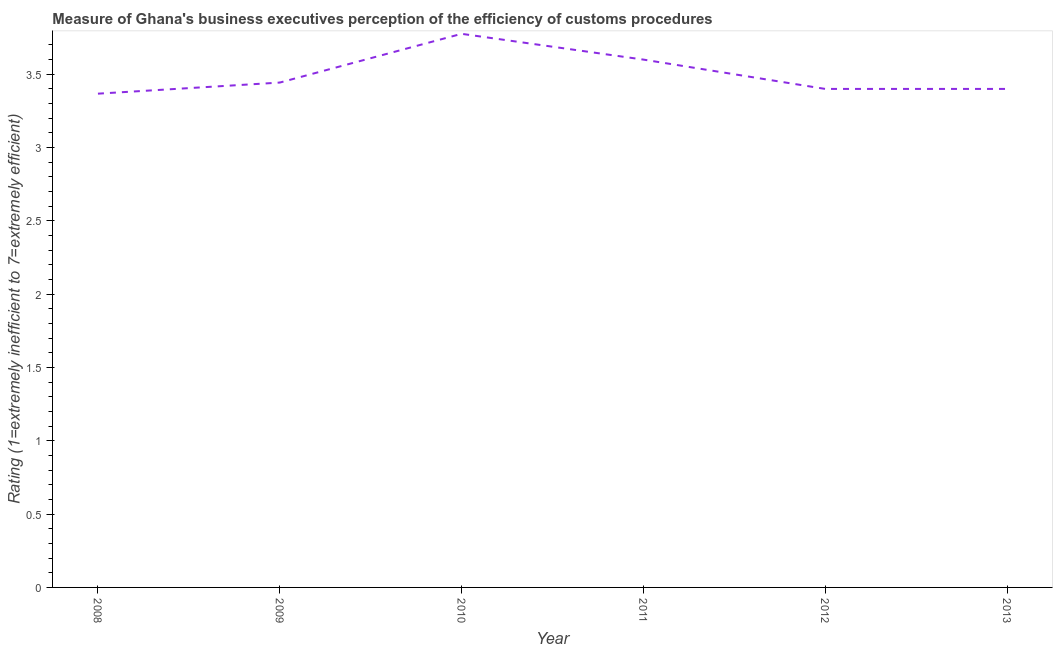Across all years, what is the maximum rating measuring burden of customs procedure?
Make the answer very short. 3.78. Across all years, what is the minimum rating measuring burden of customs procedure?
Your answer should be very brief. 3.37. In which year was the rating measuring burden of customs procedure maximum?
Provide a succinct answer. 2010. In which year was the rating measuring burden of customs procedure minimum?
Your answer should be compact. 2008. What is the sum of the rating measuring burden of customs procedure?
Make the answer very short. 20.99. What is the difference between the rating measuring burden of customs procedure in 2010 and 2011?
Give a very brief answer. 0.18. What is the average rating measuring burden of customs procedure per year?
Ensure brevity in your answer.  3.5. What is the median rating measuring burden of customs procedure?
Ensure brevity in your answer.  3.42. In how many years, is the rating measuring burden of customs procedure greater than 2.3 ?
Make the answer very short. 6. Do a majority of the years between 2009 and 2010 (inclusive) have rating measuring burden of customs procedure greater than 0.7 ?
Provide a succinct answer. Yes. What is the ratio of the rating measuring burden of customs procedure in 2010 to that in 2011?
Your answer should be very brief. 1.05. Is the rating measuring burden of customs procedure in 2010 less than that in 2011?
Provide a succinct answer. No. Is the difference between the rating measuring burden of customs procedure in 2008 and 2009 greater than the difference between any two years?
Provide a succinct answer. No. What is the difference between the highest and the second highest rating measuring burden of customs procedure?
Make the answer very short. 0.18. Is the sum of the rating measuring burden of customs procedure in 2010 and 2012 greater than the maximum rating measuring burden of customs procedure across all years?
Ensure brevity in your answer.  Yes. What is the difference between the highest and the lowest rating measuring burden of customs procedure?
Your answer should be compact. 0.41. In how many years, is the rating measuring burden of customs procedure greater than the average rating measuring burden of customs procedure taken over all years?
Keep it short and to the point. 2. How many lines are there?
Provide a succinct answer. 1. How many years are there in the graph?
Your response must be concise. 6. What is the difference between two consecutive major ticks on the Y-axis?
Offer a very short reply. 0.5. Are the values on the major ticks of Y-axis written in scientific E-notation?
Provide a short and direct response. No. Does the graph contain any zero values?
Your answer should be very brief. No. What is the title of the graph?
Make the answer very short. Measure of Ghana's business executives perception of the efficiency of customs procedures. What is the label or title of the Y-axis?
Offer a very short reply. Rating (1=extremely inefficient to 7=extremely efficient). What is the Rating (1=extremely inefficient to 7=extremely efficient) in 2008?
Offer a terse response. 3.37. What is the Rating (1=extremely inefficient to 7=extremely efficient) in 2009?
Offer a very short reply. 3.44. What is the Rating (1=extremely inefficient to 7=extremely efficient) in 2010?
Provide a short and direct response. 3.78. What is the difference between the Rating (1=extremely inefficient to 7=extremely efficient) in 2008 and 2009?
Keep it short and to the point. -0.08. What is the difference between the Rating (1=extremely inefficient to 7=extremely efficient) in 2008 and 2010?
Ensure brevity in your answer.  -0.41. What is the difference between the Rating (1=extremely inefficient to 7=extremely efficient) in 2008 and 2011?
Provide a succinct answer. -0.23. What is the difference between the Rating (1=extremely inefficient to 7=extremely efficient) in 2008 and 2012?
Provide a short and direct response. -0.03. What is the difference between the Rating (1=extremely inefficient to 7=extremely efficient) in 2008 and 2013?
Provide a short and direct response. -0.03. What is the difference between the Rating (1=extremely inefficient to 7=extremely efficient) in 2009 and 2010?
Your response must be concise. -0.33. What is the difference between the Rating (1=extremely inefficient to 7=extremely efficient) in 2009 and 2011?
Provide a short and direct response. -0.16. What is the difference between the Rating (1=extremely inefficient to 7=extremely efficient) in 2009 and 2012?
Keep it short and to the point. 0.04. What is the difference between the Rating (1=extremely inefficient to 7=extremely efficient) in 2009 and 2013?
Ensure brevity in your answer.  0.04. What is the difference between the Rating (1=extremely inefficient to 7=extremely efficient) in 2010 and 2011?
Ensure brevity in your answer.  0.18. What is the difference between the Rating (1=extremely inefficient to 7=extremely efficient) in 2010 and 2012?
Offer a terse response. 0.38. What is the difference between the Rating (1=extremely inefficient to 7=extremely efficient) in 2010 and 2013?
Ensure brevity in your answer.  0.38. What is the difference between the Rating (1=extremely inefficient to 7=extremely efficient) in 2011 and 2012?
Your response must be concise. 0.2. What is the ratio of the Rating (1=extremely inefficient to 7=extremely efficient) in 2008 to that in 2010?
Ensure brevity in your answer.  0.89. What is the ratio of the Rating (1=extremely inefficient to 7=extremely efficient) in 2008 to that in 2011?
Offer a terse response. 0.94. What is the ratio of the Rating (1=extremely inefficient to 7=extremely efficient) in 2008 to that in 2012?
Provide a succinct answer. 0.99. What is the ratio of the Rating (1=extremely inefficient to 7=extremely efficient) in 2008 to that in 2013?
Provide a succinct answer. 0.99. What is the ratio of the Rating (1=extremely inefficient to 7=extremely efficient) in 2009 to that in 2010?
Make the answer very short. 0.91. What is the ratio of the Rating (1=extremely inefficient to 7=extremely efficient) in 2009 to that in 2011?
Your response must be concise. 0.96. What is the ratio of the Rating (1=extremely inefficient to 7=extremely efficient) in 2009 to that in 2013?
Your answer should be compact. 1.01. What is the ratio of the Rating (1=extremely inefficient to 7=extremely efficient) in 2010 to that in 2011?
Your answer should be compact. 1.05. What is the ratio of the Rating (1=extremely inefficient to 7=extremely efficient) in 2010 to that in 2012?
Make the answer very short. 1.11. What is the ratio of the Rating (1=extremely inefficient to 7=extremely efficient) in 2010 to that in 2013?
Make the answer very short. 1.11. What is the ratio of the Rating (1=extremely inefficient to 7=extremely efficient) in 2011 to that in 2012?
Your response must be concise. 1.06. What is the ratio of the Rating (1=extremely inefficient to 7=extremely efficient) in 2011 to that in 2013?
Your answer should be very brief. 1.06. 